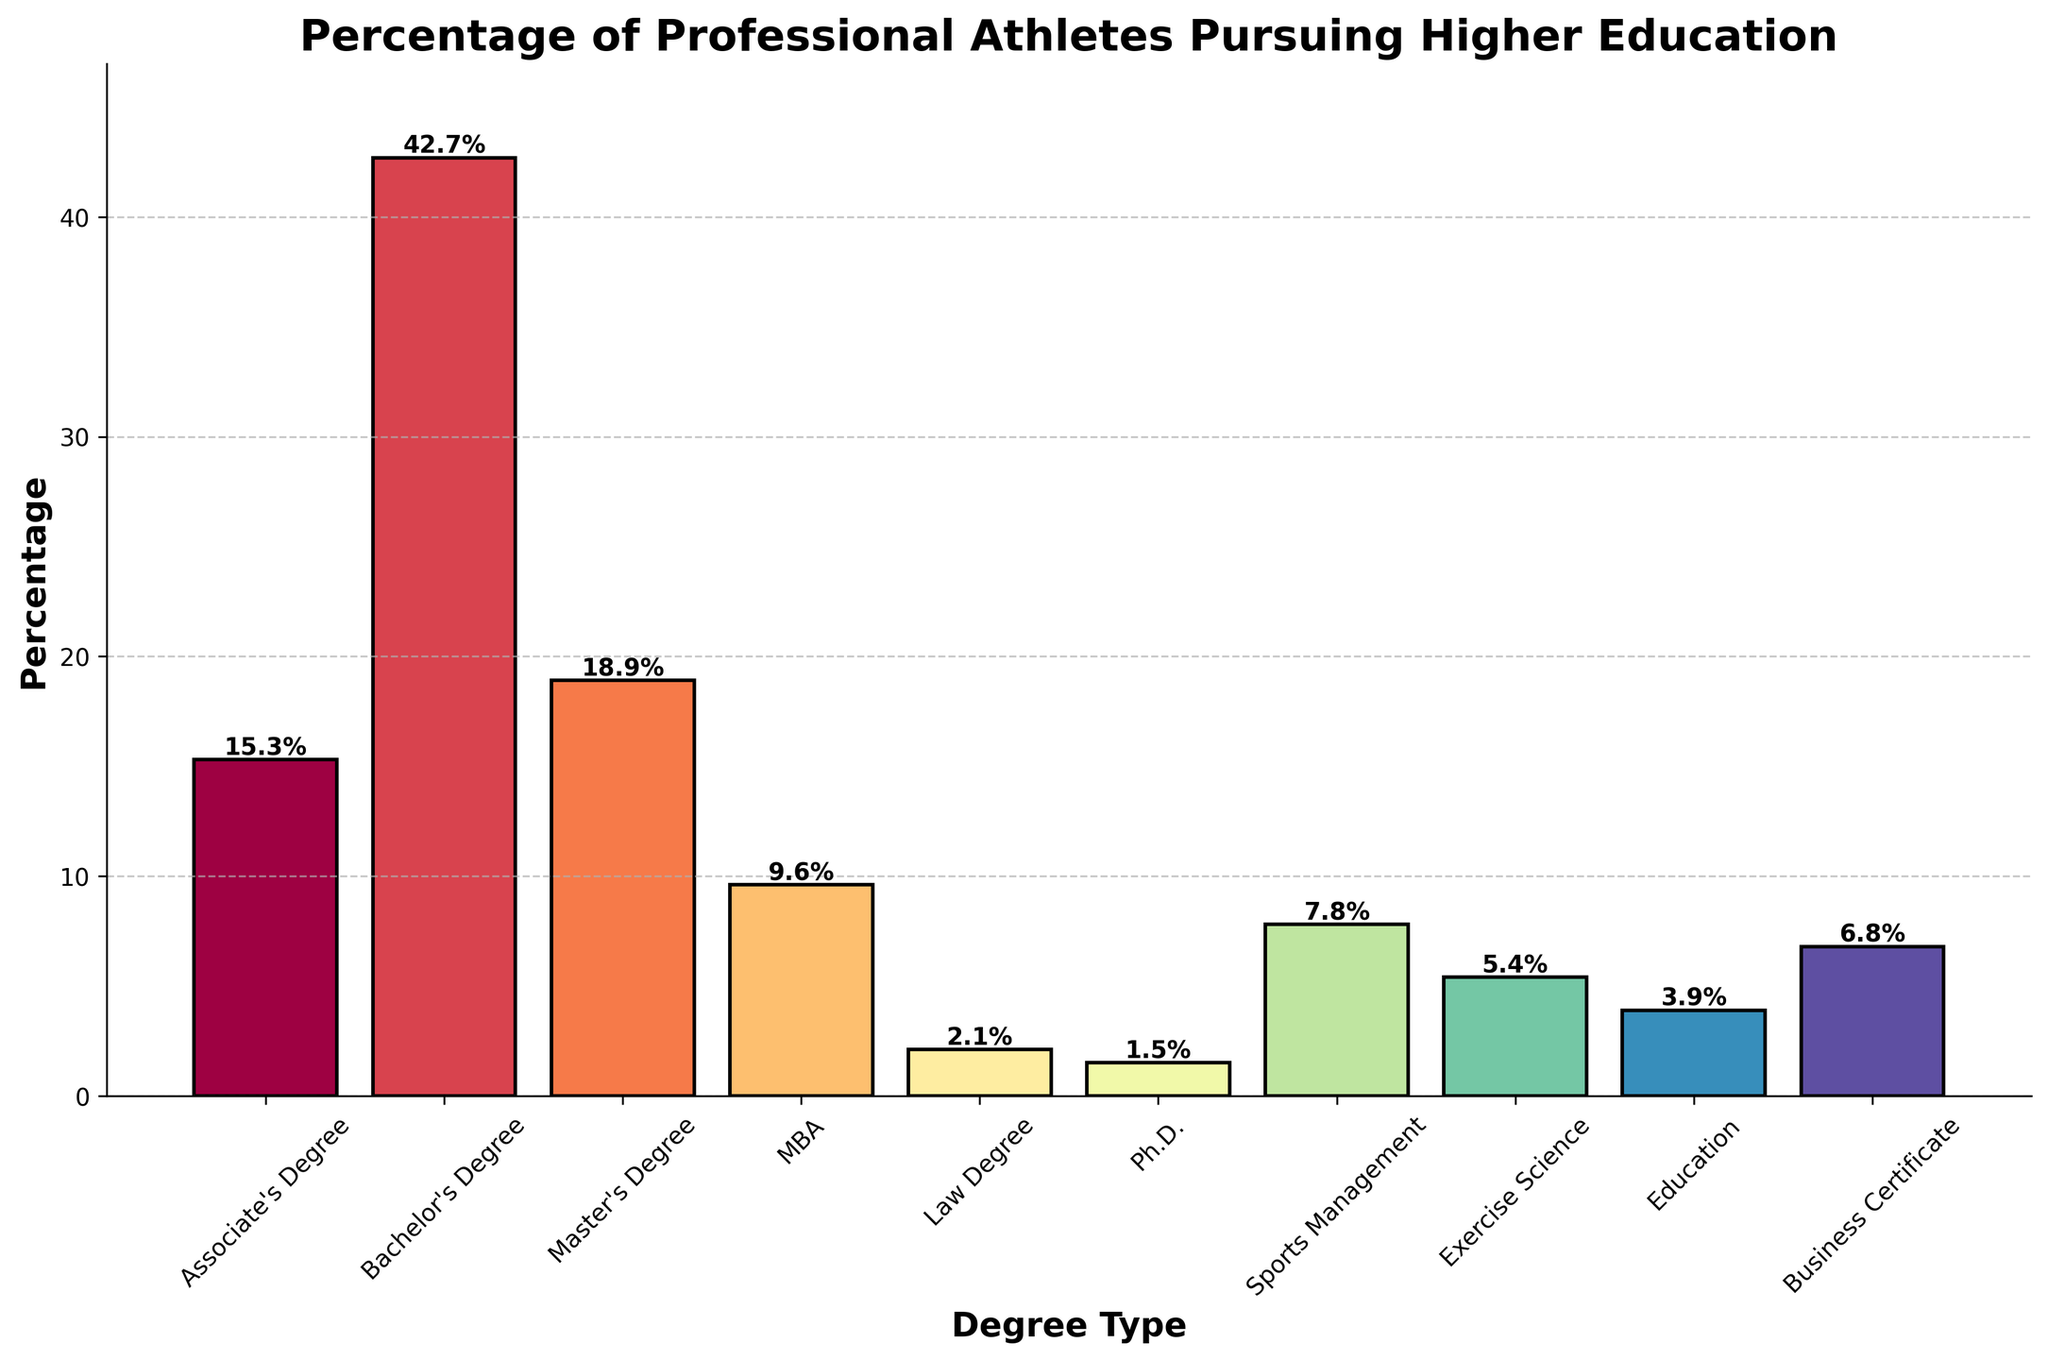What is the most common degree type pursued by professional athletes? By examining the height of the bars, the Bachelor’s Degree bar is the tallest. Hence, the Bachelor’s Degree is the most common degree type pursued by professional athletes.
Answer: Bachelor's Degree What is the total percentage of athletes pursuing a Master’s Degree or an MBA? To find the total percentage, add the percentages of Master’s Degree (18.9%) and MBA (9.6%). 18.9 + 9.6 equals 28.5.
Answer: 28.5% How does the percentage of athletes pursuing a Bachelor’s Degree compare to those pursuing an Associate’s Degree? The Bachelor’s Degree bar (42.7%) is much taller than the Associate’s Degree bar (15.3%). Therefore, the percentage of athletes pursuing a Bachelor’s Degree is higher than those pursuing an Associate’s Degree.
Answer: Bachelor's Degree is higher Which degree type has the lowest percentage of athletes pursuing it? The Ph.D. bar is the shortest one on the chart, indicating that it has the lowest percentage of athletes pursuing it at 1.5%.
Answer: Ph.D What is the combined percentage of athletes pursuing Sports Management and Exercise Science degrees? Add the percentages of Sports Management (7.8%) and Exercise Science (5.4%). 7.8 + 5.4 equals 13.2.
Answer: 13.2% What is the difference in percentage between athletes pursuing Law degrees and those pursuing Business Certificates? Subtract the percentage of athletes pursuing Law degrees (2.1%) from the percentage pursuing Business Certificates (6.8%). 6.8 - 2.1 equals 4.7.
Answer: 4.7% How much higher is the percentage of athletes with a Bachelor’s Degree compared to those with a Master’s Degree? Subtract the percentage of athletes with Master's Degrees (18.9%) from the percentage with Bachelor’s Degrees (42.7%). 42.7 - 18.9 equals 23.8.
Answer: 23.8% Among MBA and Education, which degree type has a higher percentage, and by how much? The MBA bar (9.6%) is taller than the Education bar (3.9%). Subtract 3.9 from 9.6 to find the difference. 9.6 - 3.9 equals 5.7.
Answer: MBA by 5.7% Is the percentage of athletes pursuing a Master’s Degree greater than the combined percentage of those pursuing Sports Management and Exercise Science degrees? The Master’s Degree percentage is 18.9%. The combined percentage of Sports Management (7.8%) and Exercise Science (5.4%) is 13.2%. 18.9% is greater than 13.2%.
Answer: Yes What is the difference in height between the bars for Bachelor's Degree and MBA? The Bachelor’s Degree bar is at 42.7% and the MBA bar is at 9.6%. Subtract 9.6 from 42.7 to find the height difference. 42.7 - 9.6 equals 33.1.
Answer: 33.1 